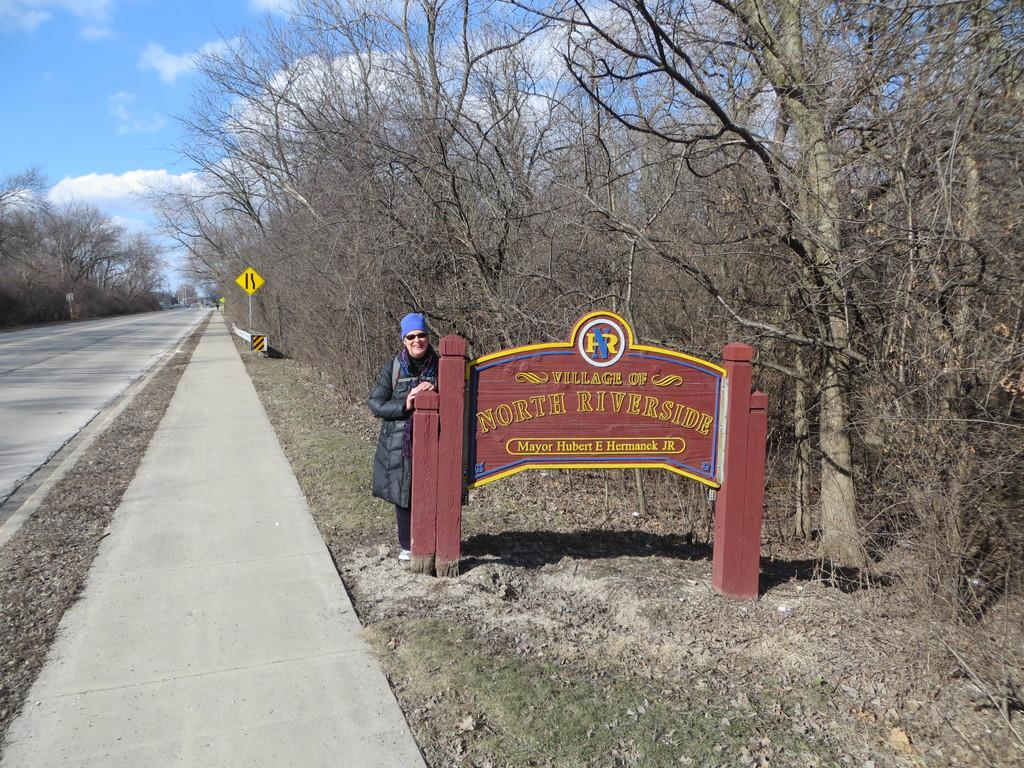<image>
Offer a succinct explanation of the picture presented. A plaque reading Village of North Riverside welcomes visitors. 